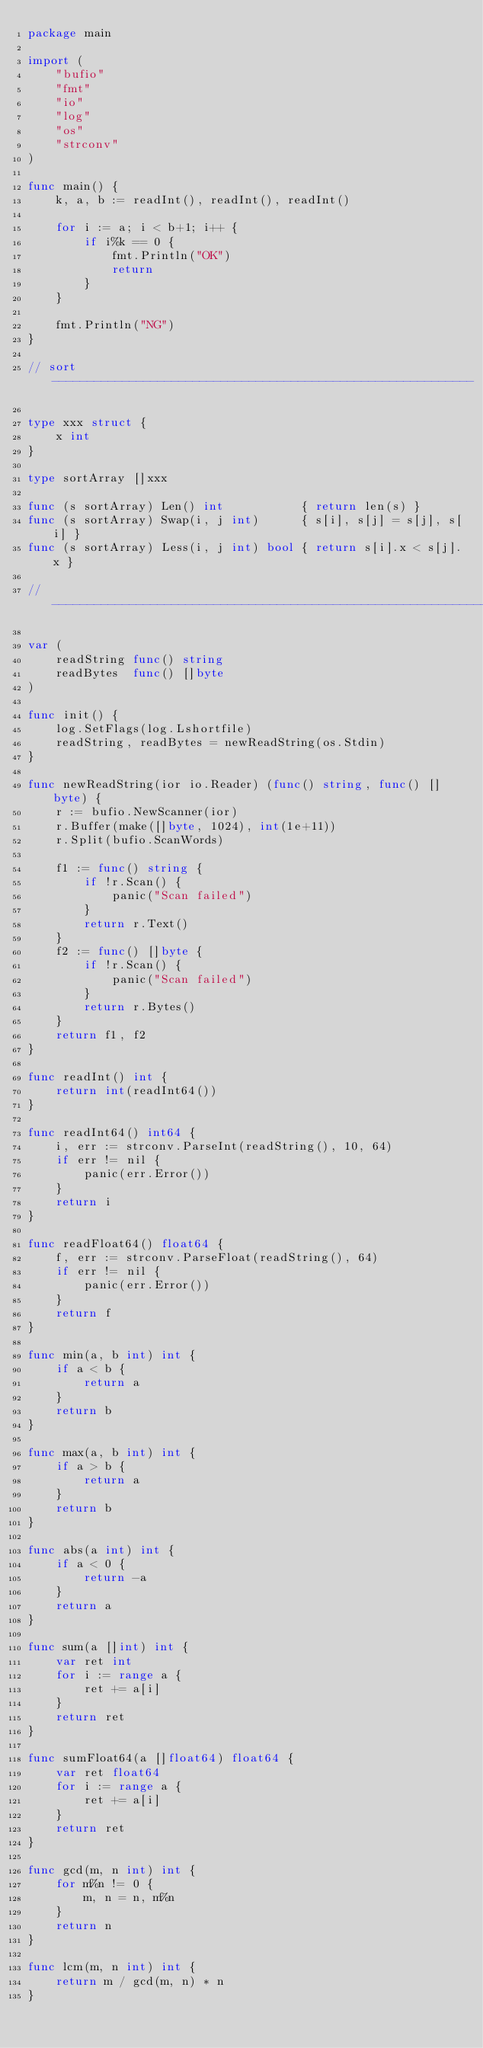Convert code to text. <code><loc_0><loc_0><loc_500><loc_500><_Go_>package main

import (
	"bufio"
	"fmt"
	"io"
	"log"
	"os"
	"strconv"
)

func main() {
	k, a, b := readInt(), readInt(), readInt()

	for i := a; i < b+1; i++ {
		if i%k == 0 {
			fmt.Println("OK")
			return
		}
	}

	fmt.Println("NG")
}

// sort ------------------------------------------------------------

type xxx struct {
	x int
}

type sortArray []xxx

func (s sortArray) Len() int           { return len(s) }
func (s sortArray) Swap(i, j int)      { s[i], s[j] = s[j], s[i] }
func (s sortArray) Less(i, j int) bool { return s[i].x < s[j].x }

// -----------------------------------------------------------------

var (
	readString func() string
	readBytes  func() []byte
)

func init() {
	log.SetFlags(log.Lshortfile)
	readString, readBytes = newReadString(os.Stdin)
}

func newReadString(ior io.Reader) (func() string, func() []byte) {
	r := bufio.NewScanner(ior)
	r.Buffer(make([]byte, 1024), int(1e+11))
	r.Split(bufio.ScanWords)

	f1 := func() string {
		if !r.Scan() {
			panic("Scan failed")
		}
		return r.Text()
	}
	f2 := func() []byte {
		if !r.Scan() {
			panic("Scan failed")
		}
		return r.Bytes()
	}
	return f1, f2
}

func readInt() int {
	return int(readInt64())
}

func readInt64() int64 {
	i, err := strconv.ParseInt(readString(), 10, 64)
	if err != nil {
		panic(err.Error())
	}
	return i
}

func readFloat64() float64 {
	f, err := strconv.ParseFloat(readString(), 64)
	if err != nil {
		panic(err.Error())
	}
	return f
}

func min(a, b int) int {
	if a < b {
		return a
	}
	return b
}

func max(a, b int) int {
	if a > b {
		return a
	}
	return b
}

func abs(a int) int {
	if a < 0 {
		return -a
	}
	return a
}

func sum(a []int) int {
	var ret int
	for i := range a {
		ret += a[i]
	}
	return ret
}

func sumFloat64(a []float64) float64 {
	var ret float64
	for i := range a {
		ret += a[i]
	}
	return ret
}

func gcd(m, n int) int {
	for m%n != 0 {
		m, n = n, m%n
	}
	return n
}

func lcm(m, n int) int {
	return m / gcd(m, n) * n
}
</code> 